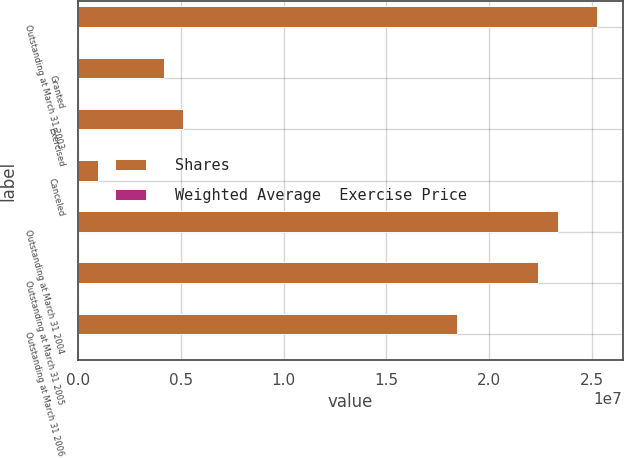Convert chart to OTSL. <chart><loc_0><loc_0><loc_500><loc_500><stacked_bar_chart><ecel><fcel>Outstanding at March 31 2003<fcel>Granted<fcel>Exercised<fcel>Canceled<fcel>Outstanding at March 31 2004<fcel>Outstanding at March 31 2005<fcel>Outstanding at March 31 2006<nl><fcel>Shares<fcel>2.52349e+07<fcel>4.18635e+06<fcel>5.11429e+06<fcel>947047<fcel>2.33599e+07<fcel>2.23707e+07<fcel>1.84504e+07<nl><fcel>Weighted Average  Exercise Price<fcel>15.45<fcel>20.68<fcel>8.79<fcel>21.53<fcel>17.6<fcel>19.19<fcel>20.97<nl></chart> 